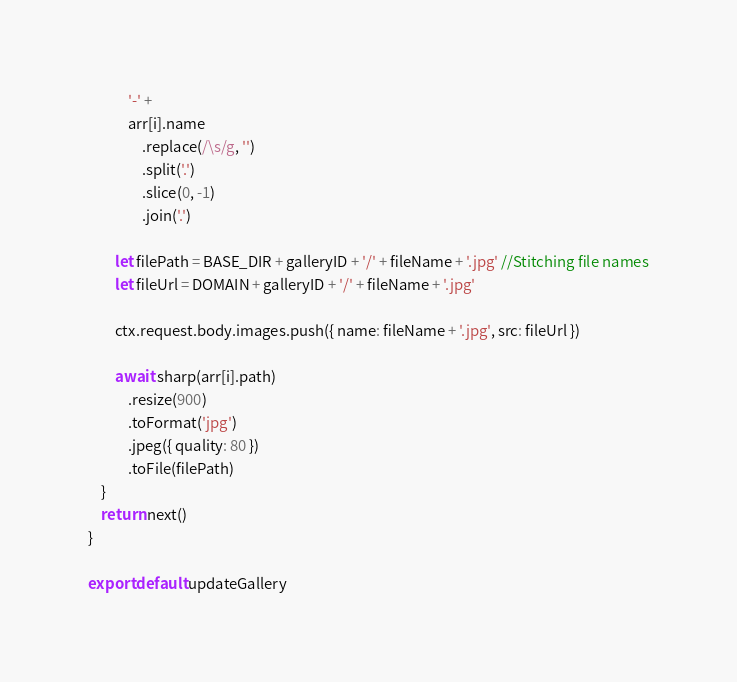<code> <loc_0><loc_0><loc_500><loc_500><_JavaScript_>            '-' +
            arr[i].name
                .replace(/\s/g, '')
                .split('.')
                .slice(0, -1)
                .join('.')

        let filePath = BASE_DIR + galleryID + '/' + fileName + '.jpg' //Stitching file names
        let fileUrl = DOMAIN + galleryID + '/' + fileName + '.jpg'

        ctx.request.body.images.push({ name: fileName + '.jpg', src: fileUrl })

        await sharp(arr[i].path)
            .resize(900)
            .toFormat('jpg')
            .jpeg({ quality: 80 })
            .toFile(filePath)
    }
    return next()
}

export default updateGallery
</code> 